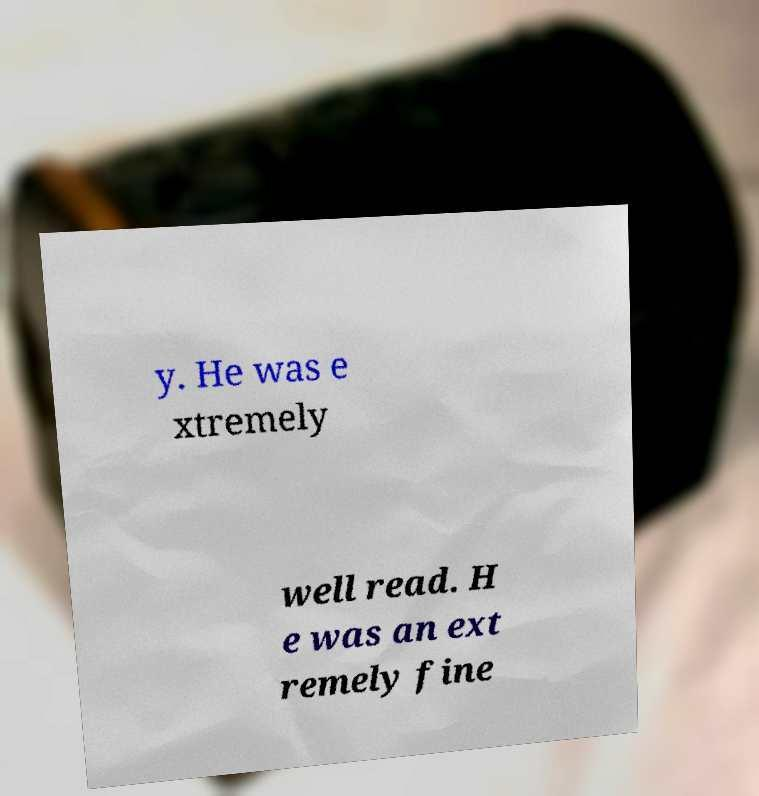Please read and relay the text visible in this image. What does it say? y. He was e xtremely well read. H e was an ext remely fine 